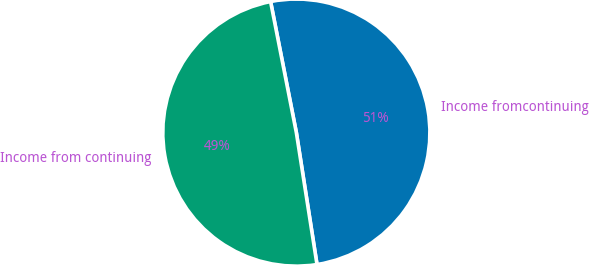<chart> <loc_0><loc_0><loc_500><loc_500><pie_chart><fcel>Income fromcontinuing<fcel>Income from continuing<nl><fcel>50.62%<fcel>49.38%<nl></chart> 